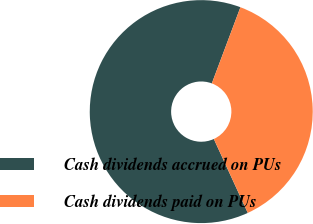Convert chart to OTSL. <chart><loc_0><loc_0><loc_500><loc_500><pie_chart><fcel>Cash dividends accrued on PUs<fcel>Cash dividends paid on PUs<nl><fcel>62.57%<fcel>37.43%<nl></chart> 